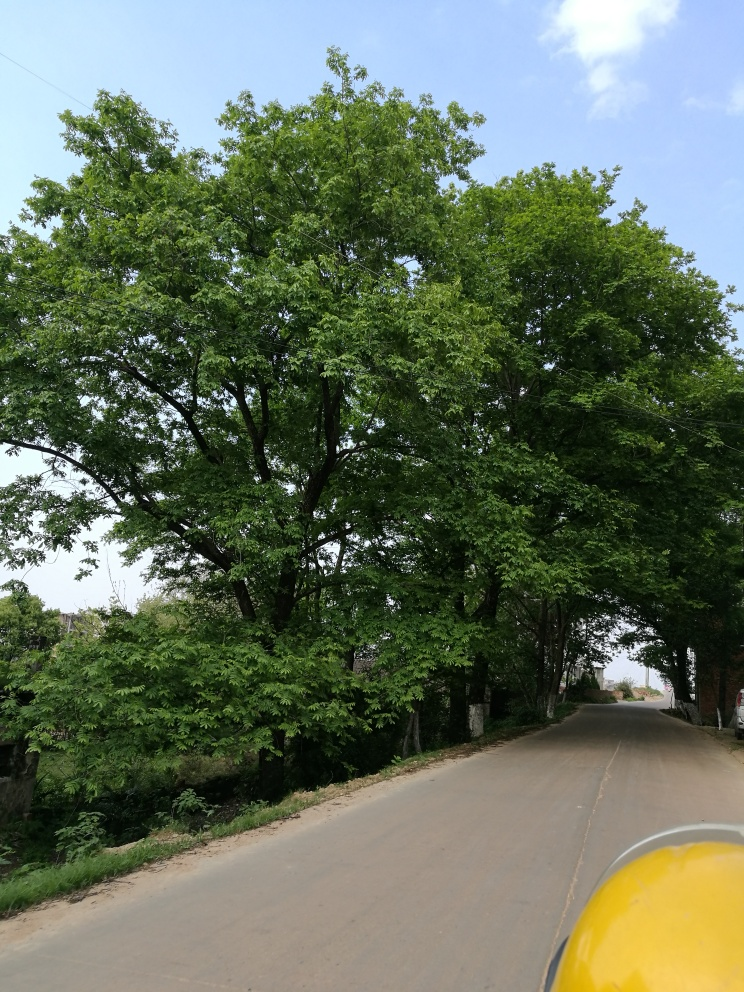What can you infer about the location and time of day this photo was taken? The photo appears to be taken on a rural or suburban road, given the lack of urban infrastructure and the natural landscape. The lighting suggests it could be midday or early afternoon, as the sun seems high enough to cast only small shadows and the sky is brightly lit, though slightly overcast. Does it look like it will rain soon? While the sky appears overcast, suggesting the potential for rain, there's insufficient visual evidence in the image to confidently predict imminent rainfall. A weather forecast would provide a more accurate prediction. 